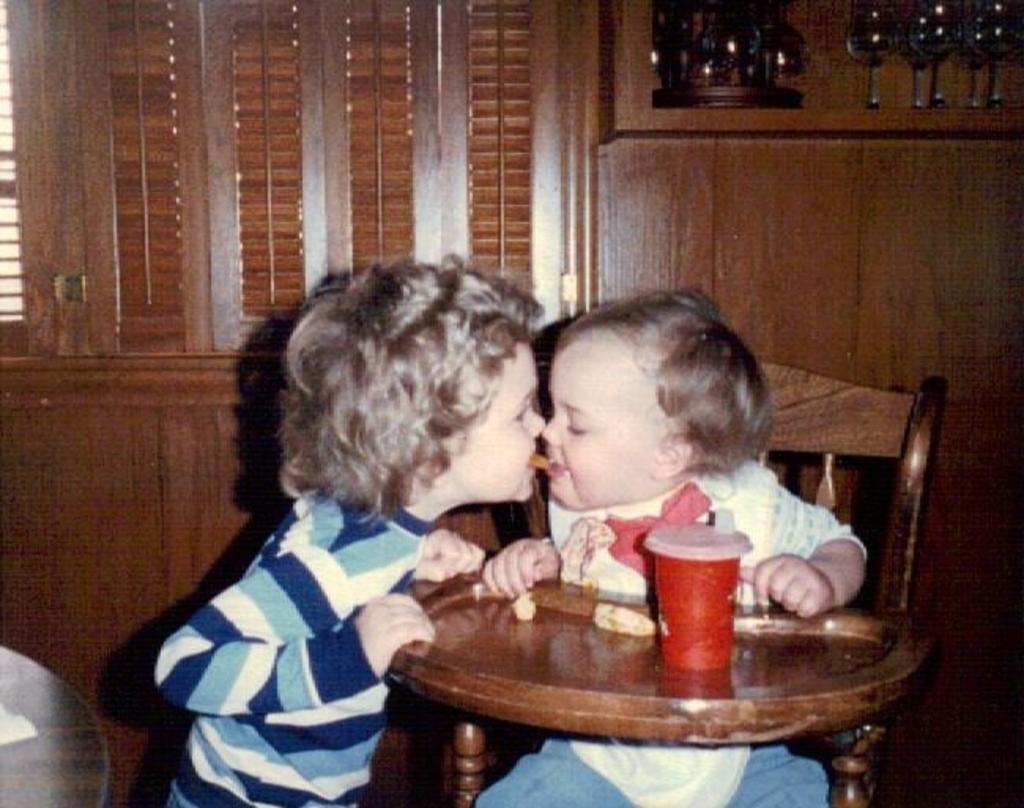In one or two sentences, can you explain what this image depicts? In this picture we can see two children's and one is sitting on chair and other is keeping something food in his mouth and in front of them we have table and on table we can see glass and in the background we can see wall, glasses. 